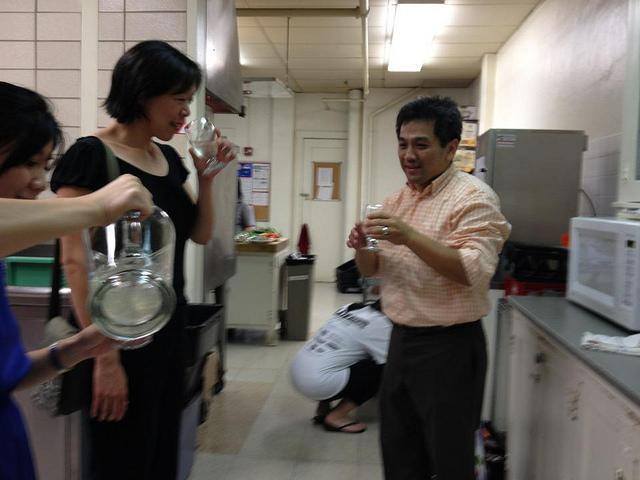How many people are there?
Give a very brief answer. 4. How many birds are there?
Give a very brief answer. 0. 